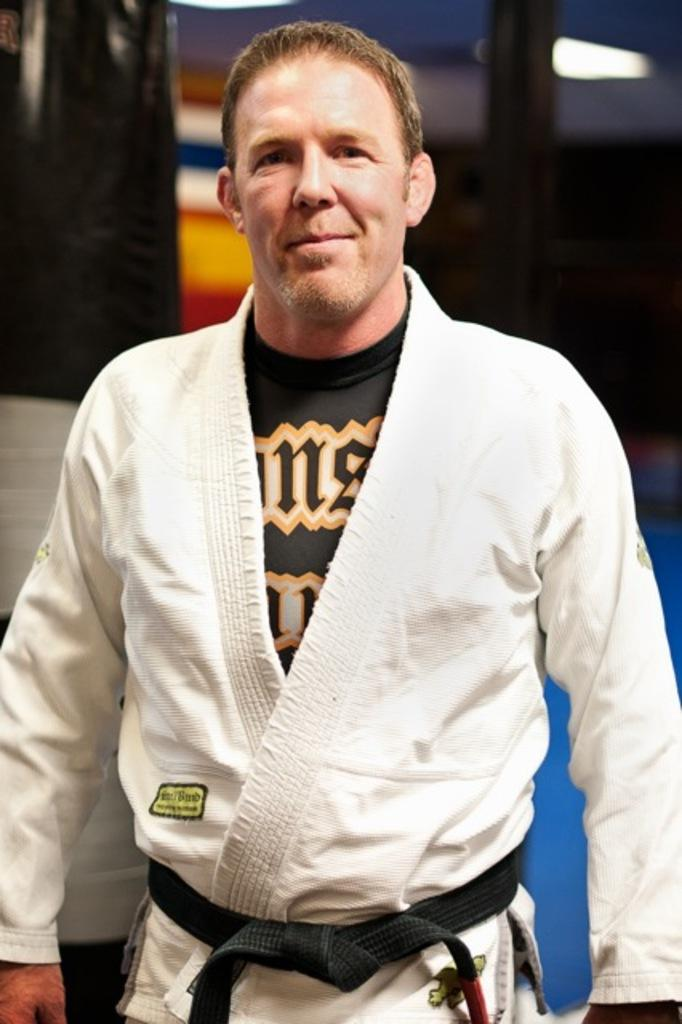Who is present in the image? There is a man in the image. What is the man wearing? The man is wearing a white dress and a belt. What is the man's expression in the image? The man is watching and smiling. Can you describe the background of the image? The background of the image is blurry. What can be seen in the image besides the man? There is light visible in the image, and there is a pole present. What type of coil is being used by the man in the image? There is no coil present in the image; the man is wearing a white dress and a belt. How many trains can be seen in the image? There are no trains present in the image; it features a man wearing a white dress and a belt, with a blurry background and a pole. 